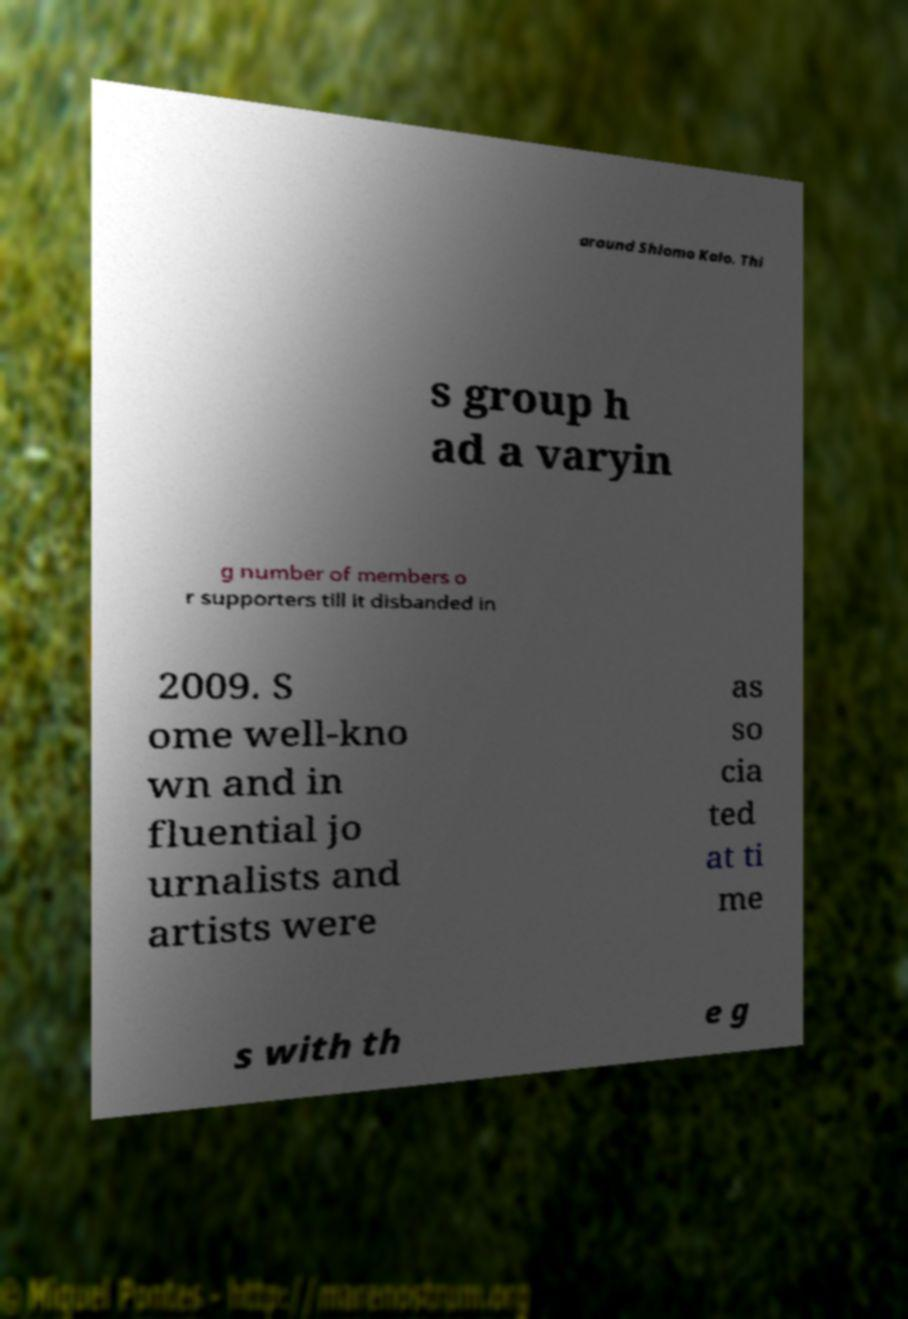For documentation purposes, I need the text within this image transcribed. Could you provide that? around Shlomo Kalo. Thi s group h ad a varyin g number of members o r supporters till it disbanded in 2009. S ome well-kno wn and in fluential jo urnalists and artists were as so cia ted at ti me s with th e g 